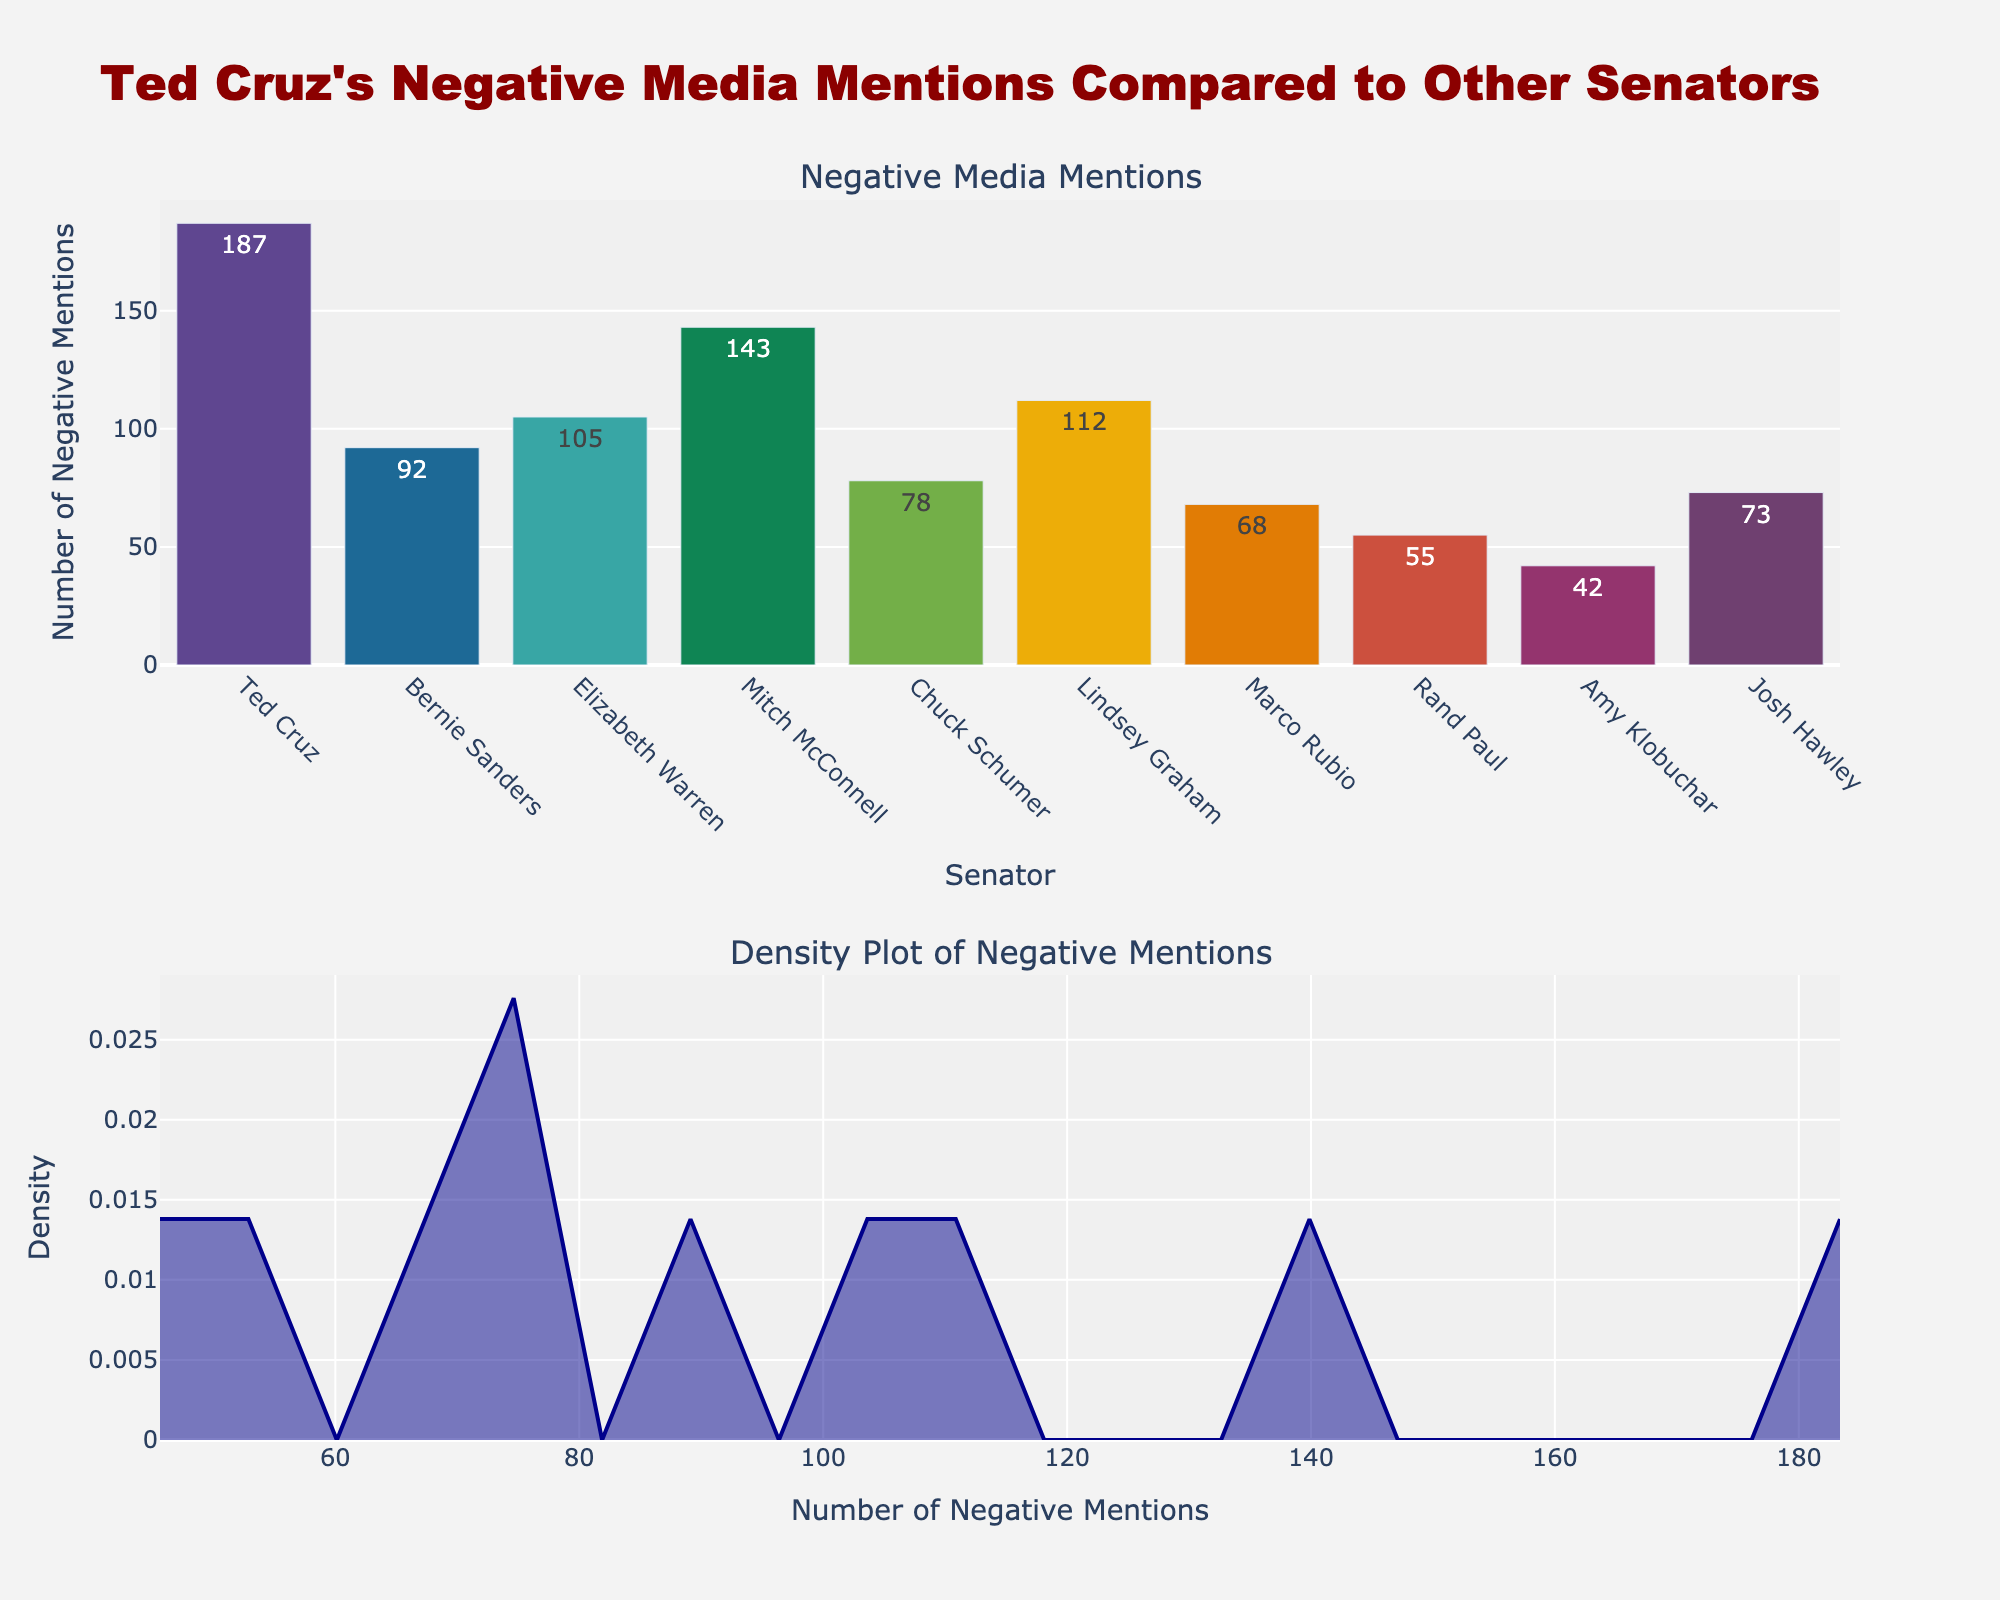What's the title of the figure? The title is displayed at the top of the figure. It summarizes the content of the figure related to Ted Cruz's negative media mentions.
Answer: Ted Cruz's Negative Media Mentions Compared to Other Senators Which senator has the highest number of negative media mentions? By looking at the height of the bars in the bar plot, you can identify the senator with the highest bar.
Answer: Ted Cruz How many negative media mentions did Marco Rubio receive? You need to locate Marco Rubio on the x-axis of the bar plot and read the corresponding bar height.
Answer: 68 What is the range of negative media mentions among the evaluated senators? Identify the minimum and maximum values in the bar plot: the minimum value is for Amy Klobuchar (42), and the maximum value is for Ted Cruz (187). The range is the difference between them.
Answer: 145 What's the median number of negative media mentions? To find the median, list the negative mentions and find the middle value. The mentions are 42, 55, 68, 73, 78, 92, 105, 112, 143, 187. The median is the average of the 5th and 6th values.
Answer: 85 Which senators received fewer negative media mentions than Bernie Sanders? Identify the senators with bar heights lower than Bernie Sanders's bar (92 mentions): Senators with bars representing fewer mentions are Amy Klobuchar, Rand Paul, Marco Rubio, Josh Hawley, and Chuck Schumer.
Answer: Amy Klobuchar, Rand Paul, Marco Rubio, Josh Hawley, Chuck Schumer How does the density plot illustrate the distribution of negative mentions? The density plot shows the frequency of different ranges of negative mentions. Peaks in the plot indicate common values. The density decreases as the mentions deviate from the central values.
Answer: It shows the distribution with peaks and varying density Compare the negative media mentions of Lindsey Graham to Mitch McConnell. Locate Lindsey Graham and Mitch McConnell on the bar plot and compare the heights of their bars. Lindsey Graham has 112 mentions, and Mitch McConnell has 143 mentions. McConnell has more negative mentions.
Answer: Mitch McConnell has more negative mentions How many senators have negative media mentions above 100? Count the number of bars with heights surpassing 100 negative mentions. Those senators are Ted Cruz, Mitch McConnell, Elizabeth Warren, and Lindsey Graham.
Answer: 4 What does the density plot show about senators with negative mentions around 100? Examine the density plot around the x-axis value of 100. The height of the line indicates the frequency of mentions around this value. Notice that there is a peak around this range.
Answer: High density around 100 mentions, indicating common occurrences in this range 